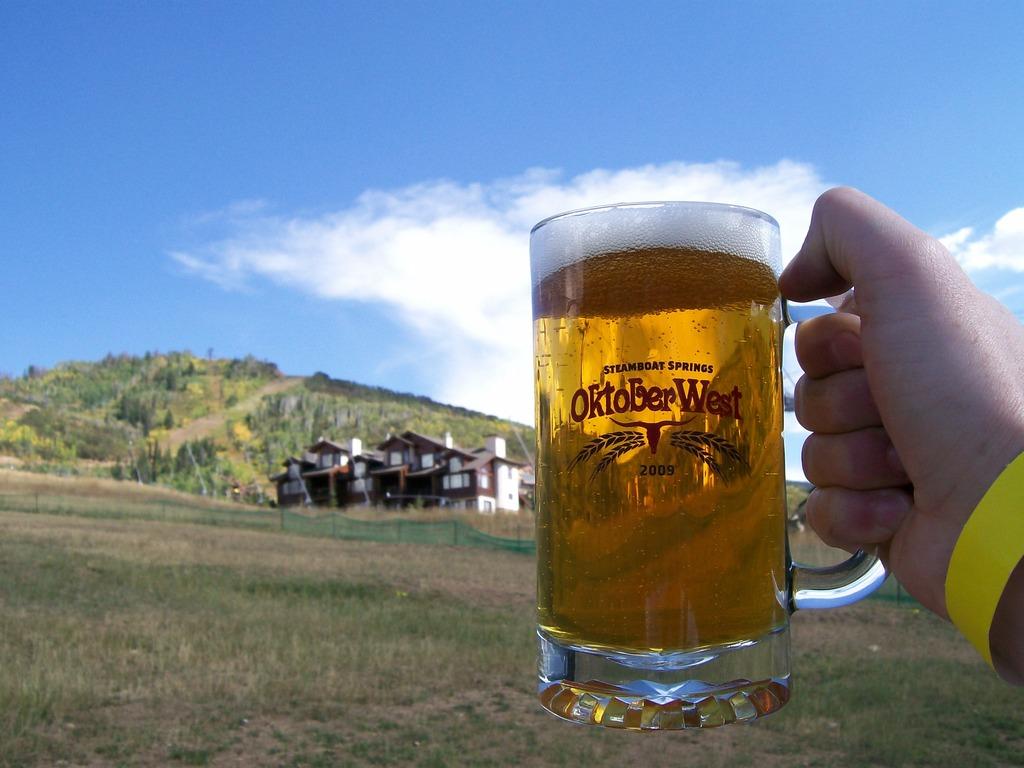What does it say on the mug?
Keep it short and to the point. Oktober west. 